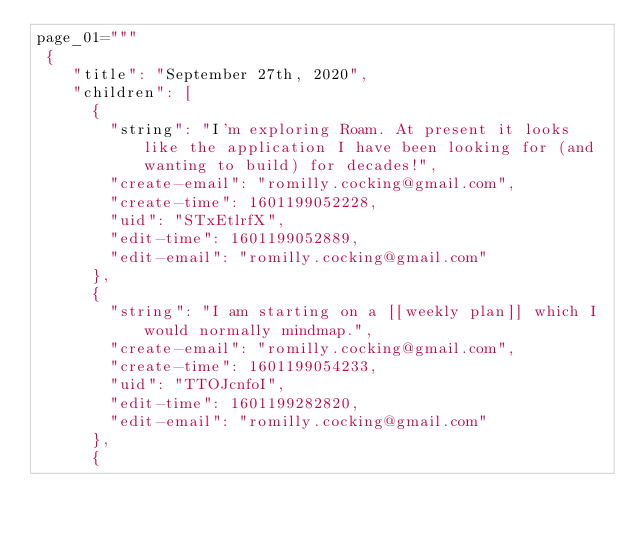<code> <loc_0><loc_0><loc_500><loc_500><_Python_>page_01="""
 {
    "title": "September 27th, 2020",
    "children": [
      {
        "string": "I'm exploring Roam. At present it looks like the application I have been looking for (and wanting to build) for decades!",
        "create-email": "romilly.cocking@gmail.com",
        "create-time": 1601199052228,
        "uid": "STxEtlrfX",
        "edit-time": 1601199052889,
        "edit-email": "romilly.cocking@gmail.com"
      },
      {
        "string": "I am starting on a [[weekly plan]] which I would normally mindmap.",
        "create-email": "romilly.cocking@gmail.com",
        "create-time": 1601199054233,
        "uid": "TTOJcnfoI",
        "edit-time": 1601199282820,
        "edit-email": "romilly.cocking@gmail.com"
      },
      {</code> 